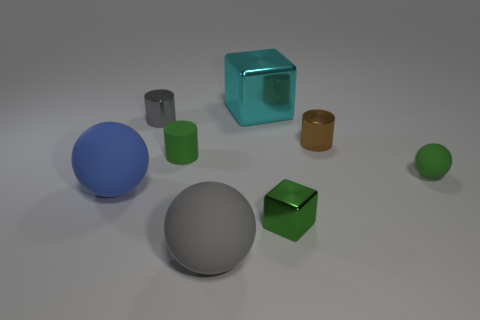Add 2 green metallic balls. How many objects exist? 10 Subtract all cubes. How many objects are left? 6 Add 7 rubber cylinders. How many rubber cylinders are left? 8 Add 5 large blue metal blocks. How many large blue metal blocks exist? 5 Subtract 1 gray cylinders. How many objects are left? 7 Subtract all small gray shiny objects. Subtract all spheres. How many objects are left? 4 